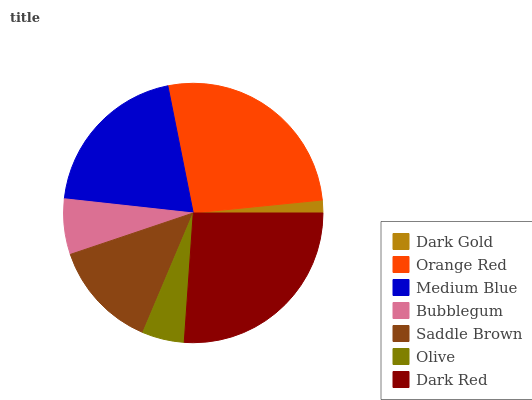Is Dark Gold the minimum?
Answer yes or no. Yes. Is Orange Red the maximum?
Answer yes or no. Yes. Is Medium Blue the minimum?
Answer yes or no. No. Is Medium Blue the maximum?
Answer yes or no. No. Is Orange Red greater than Medium Blue?
Answer yes or no. Yes. Is Medium Blue less than Orange Red?
Answer yes or no. Yes. Is Medium Blue greater than Orange Red?
Answer yes or no. No. Is Orange Red less than Medium Blue?
Answer yes or no. No. Is Saddle Brown the high median?
Answer yes or no. Yes. Is Saddle Brown the low median?
Answer yes or no. Yes. Is Bubblegum the high median?
Answer yes or no. No. Is Dark Red the low median?
Answer yes or no. No. 